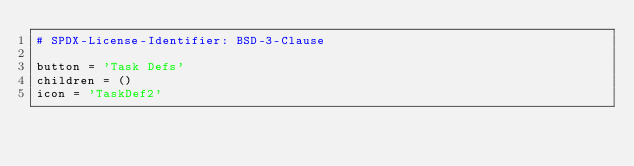<code> <loc_0><loc_0><loc_500><loc_500><_Python_># SPDX-License-Identifier: BSD-3-Clause

button = 'Task Defs'
children = ()
icon = 'TaskDef2'
</code> 